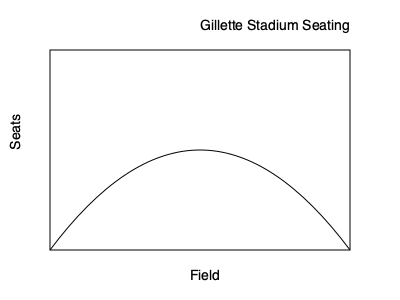At Gillette Stadium, home of the New England Patriots, the seating arrangement follows a parabolic curve to optimize viewing angles. The curve can be modeled by the equation $y = ax^2 + bx + c$, where $y$ represents the height of the seats and $x$ represents the horizontal distance from the center of the field. If the stadium is 300 feet wide and the highest seat is 100 feet above field level, determine the equation of the parabola that represents the optimal seating arrangement. To solve this problem, we'll follow these steps:

1) The parabola's vertex is at the center of the stadium, which represents the lowest point of the seating arrangement. Let's set the origin (0,0) at this point.

2) Given the stadium's width is 300 feet, the parabola extends 150 feet on each side of the origin. So, our parabola passes through the points (-150, 100) and (150, 100).

3) The general form of a parabola is $y = ax^2 + bx + c$. Since the vertex is at (0,0), we know that $c = 0$ and $b = 0$. So our equation simplifies to $y = ax^2$.

4) We can use either point to solve for $a$. Let's use (150, 100):

   $100 = a(150)^2$
   $100 = 22500a$
   $a = \frac{100}{22500} = \frac{1}{225}$

5) Therefore, the equation of the parabola is:

   $y = \frac{1}{225}x^2$

This equation represents the optimal seating arrangement that maximizes viewing angles for all seats in Gillette Stadium.
Answer: $y = \frac{1}{225}x^2$ 